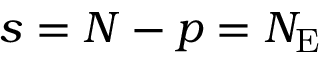<formula> <loc_0><loc_0><loc_500><loc_500>s = N - p = N _ { E }</formula> 